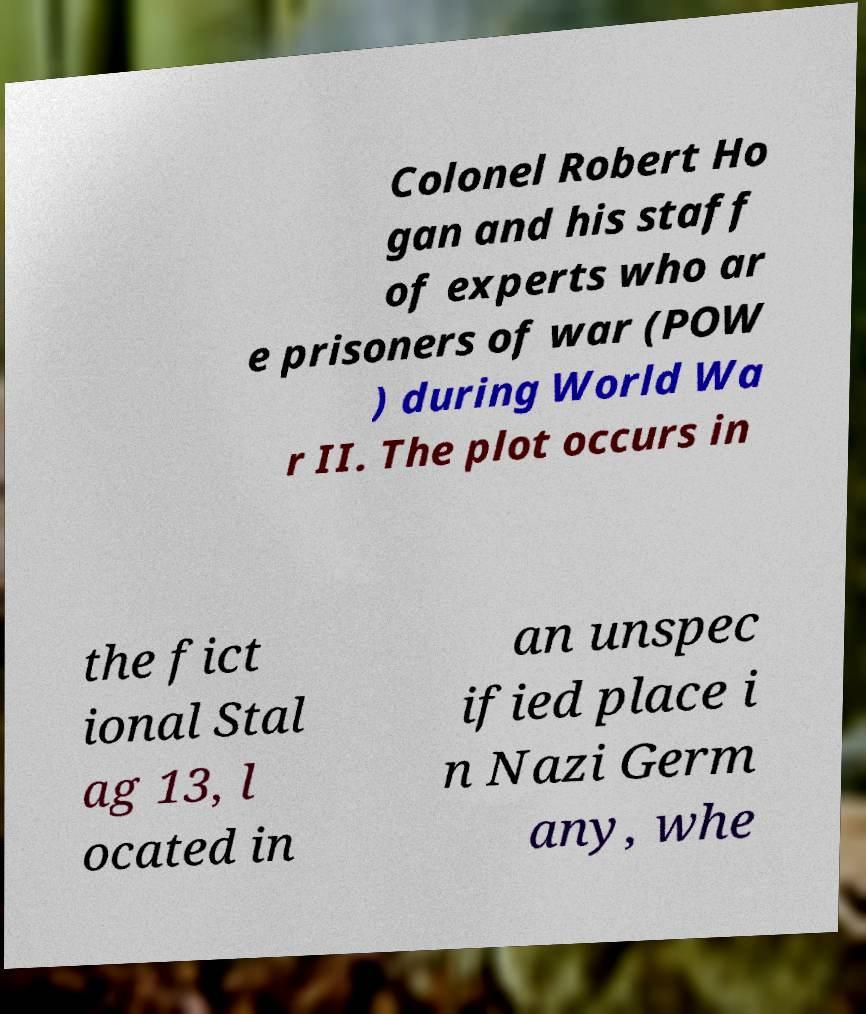For documentation purposes, I need the text within this image transcribed. Could you provide that? Colonel Robert Ho gan and his staff of experts who ar e prisoners of war (POW ) during World Wa r II. The plot occurs in the fict ional Stal ag 13, l ocated in an unspec ified place i n Nazi Germ any, whe 